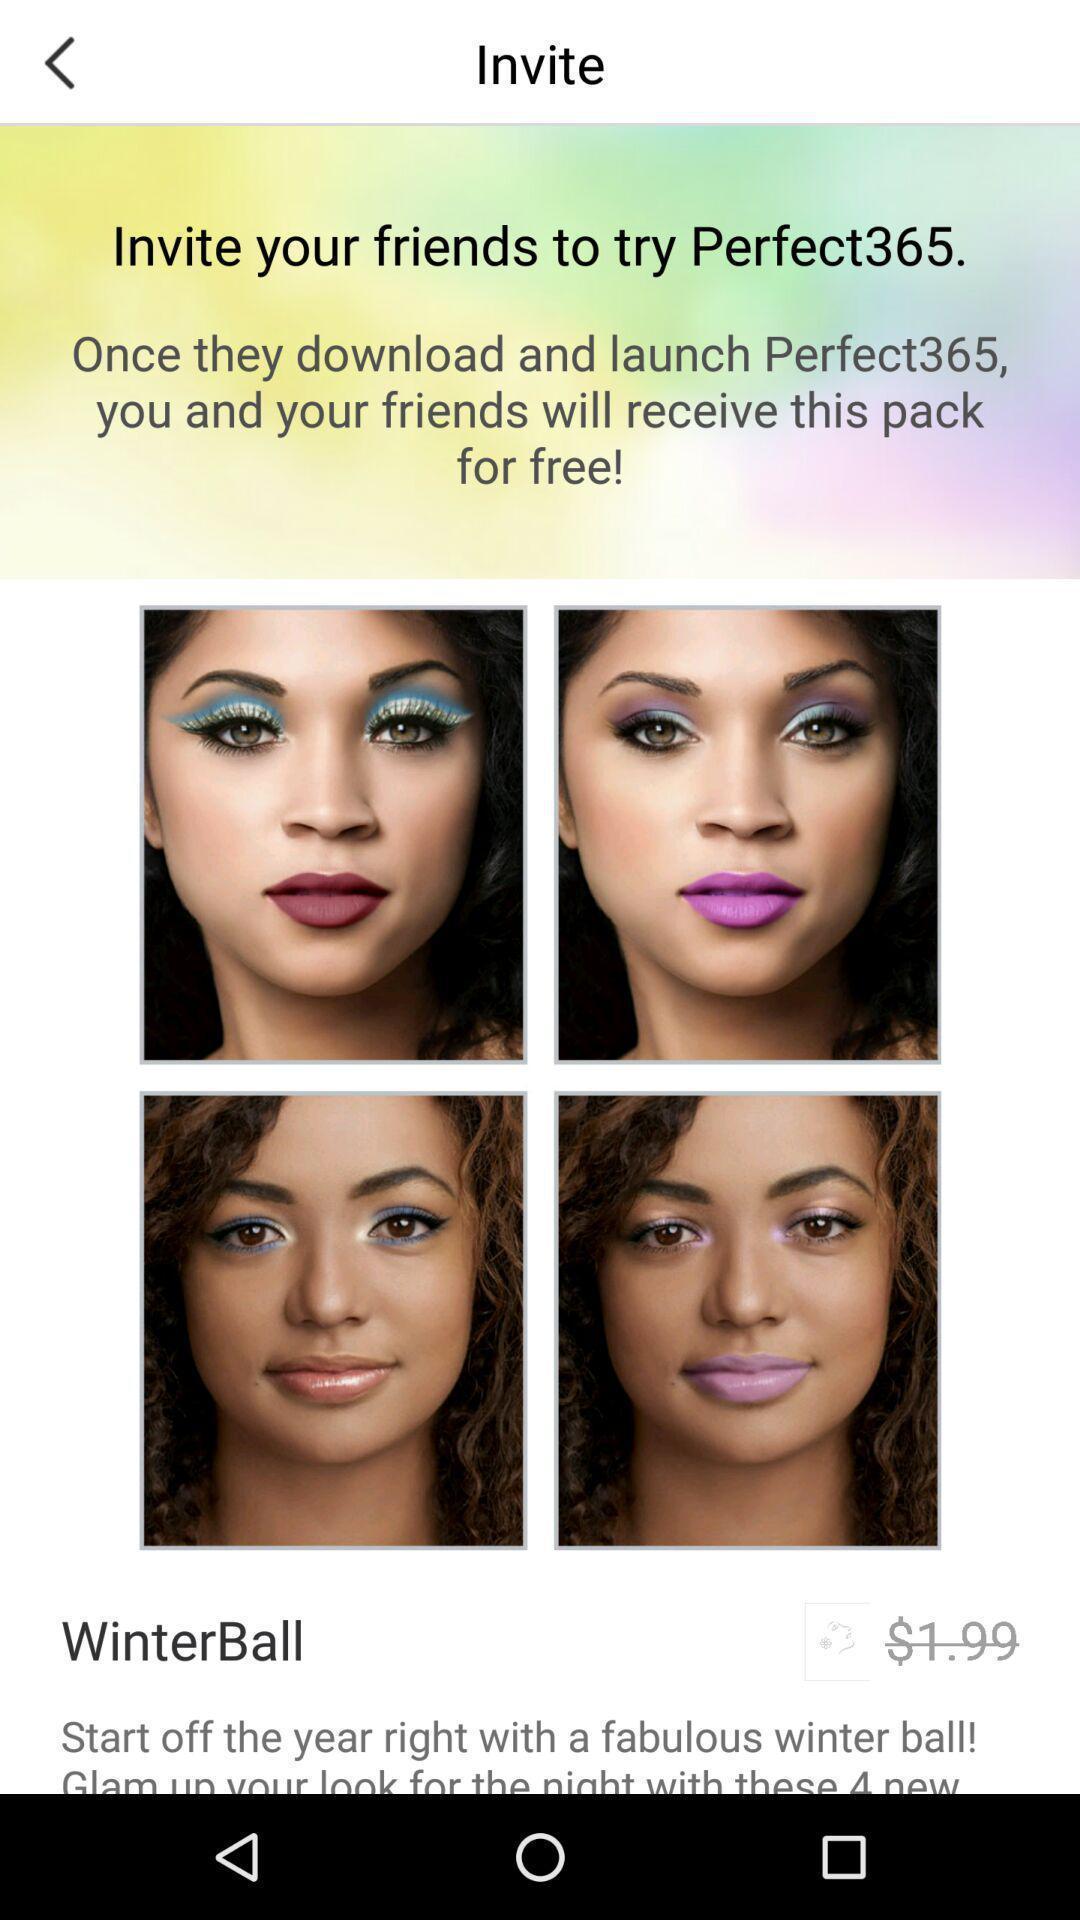What is the overall content of this screenshot? Page shows to invite your friends to try an application. 